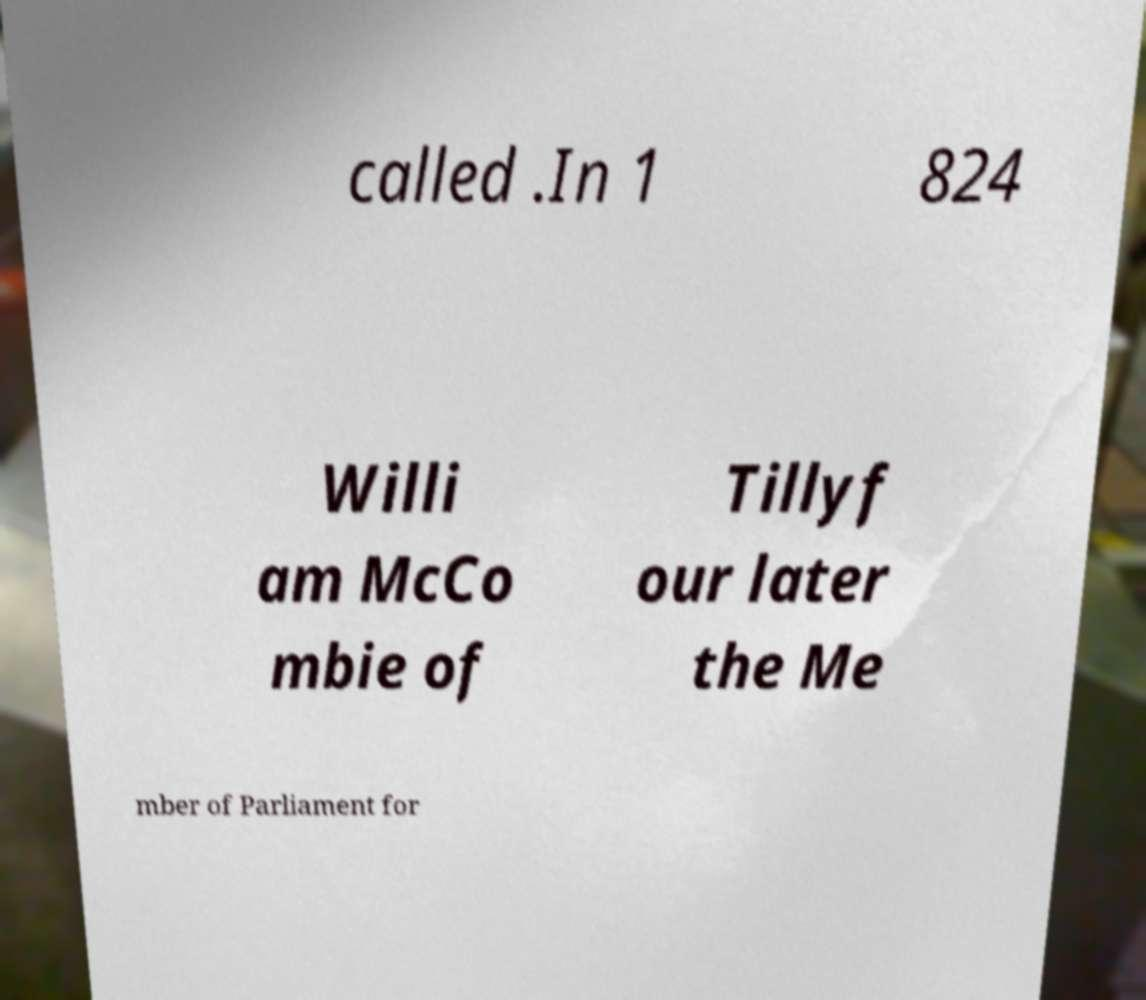Can you read and provide the text displayed in the image?This photo seems to have some interesting text. Can you extract and type it out for me? called .In 1 824 Willi am McCo mbie of Tillyf our later the Me mber of Parliament for 